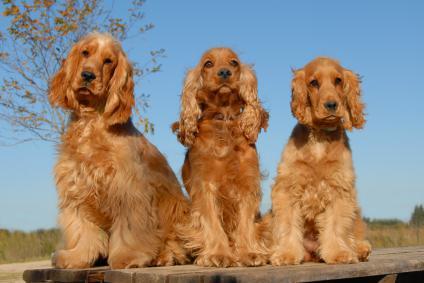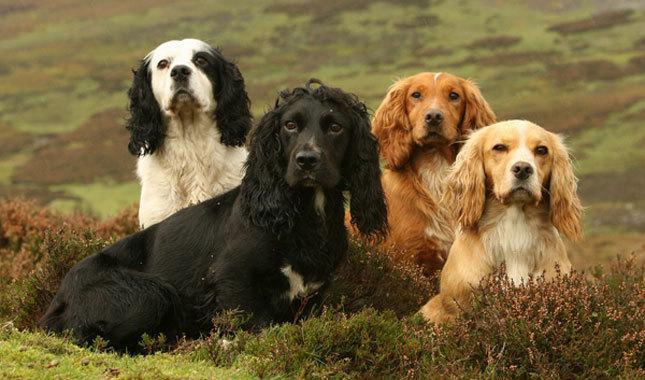The first image is the image on the left, the second image is the image on the right. Examine the images to the left and right. Is the description "An image includes at least three dogs of different colors." accurate? Answer yes or no. Yes. The first image is the image on the left, the second image is the image on the right. For the images shown, is this caption "The right image contains exactly two dogs." true? Answer yes or no. No. 